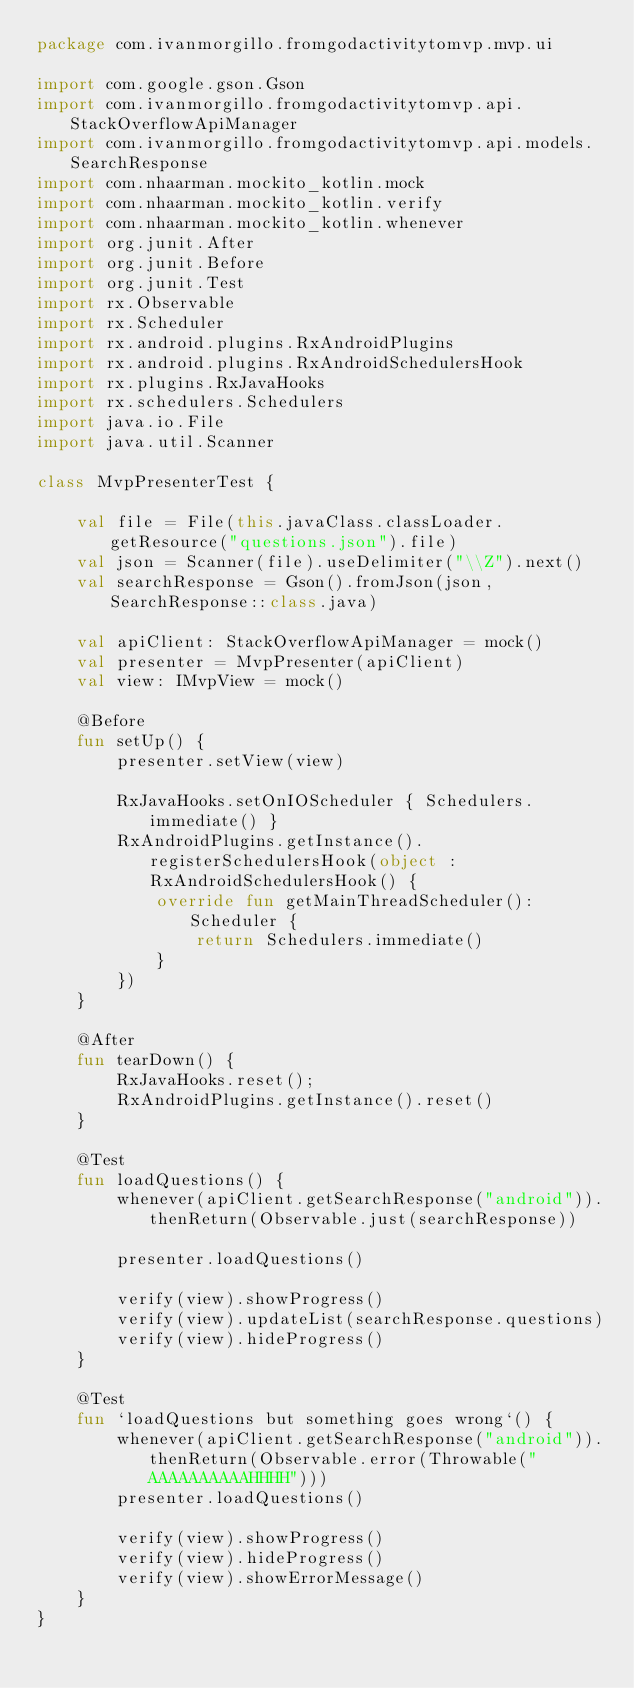<code> <loc_0><loc_0><loc_500><loc_500><_Kotlin_>package com.ivanmorgillo.fromgodactivitytomvp.mvp.ui

import com.google.gson.Gson
import com.ivanmorgillo.fromgodactivitytomvp.api.StackOverflowApiManager
import com.ivanmorgillo.fromgodactivitytomvp.api.models.SearchResponse
import com.nhaarman.mockito_kotlin.mock
import com.nhaarman.mockito_kotlin.verify
import com.nhaarman.mockito_kotlin.whenever
import org.junit.After
import org.junit.Before
import org.junit.Test
import rx.Observable
import rx.Scheduler
import rx.android.plugins.RxAndroidPlugins
import rx.android.plugins.RxAndroidSchedulersHook
import rx.plugins.RxJavaHooks
import rx.schedulers.Schedulers
import java.io.File
import java.util.Scanner

class MvpPresenterTest {

    val file = File(this.javaClass.classLoader.getResource("questions.json").file)
    val json = Scanner(file).useDelimiter("\\Z").next()
    val searchResponse = Gson().fromJson(json, SearchResponse::class.java)

    val apiClient: StackOverflowApiManager = mock()
    val presenter = MvpPresenter(apiClient)
    val view: IMvpView = mock()

    @Before
    fun setUp() {
        presenter.setView(view)

        RxJavaHooks.setOnIOScheduler { Schedulers.immediate() }
        RxAndroidPlugins.getInstance().registerSchedulersHook(object : RxAndroidSchedulersHook() {
            override fun getMainThreadScheduler(): Scheduler {
                return Schedulers.immediate()
            }
        })
    }

    @After
    fun tearDown() {
        RxJavaHooks.reset();
        RxAndroidPlugins.getInstance().reset()
    }

    @Test
    fun loadQuestions() {
        whenever(apiClient.getSearchResponse("android")).thenReturn(Observable.just(searchResponse))

        presenter.loadQuestions()

        verify(view).showProgress()
        verify(view).updateList(searchResponse.questions)
        verify(view).hideProgress()
    }

    @Test
    fun `loadQuestions but something goes wrong`() {
        whenever(apiClient.getSearchResponse("android")).thenReturn(Observable.error(Throwable("AAAAAAAAAAHHHH")))
        presenter.loadQuestions()

        verify(view).showProgress()
        verify(view).hideProgress()
        verify(view).showErrorMessage()
    }
}
</code> 